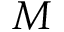Convert formula to latex. <formula><loc_0><loc_0><loc_500><loc_500>M</formula> 